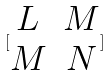Convert formula to latex. <formula><loc_0><loc_0><loc_500><loc_500>[ \begin{matrix} L & M \\ M & N \end{matrix} ]</formula> 